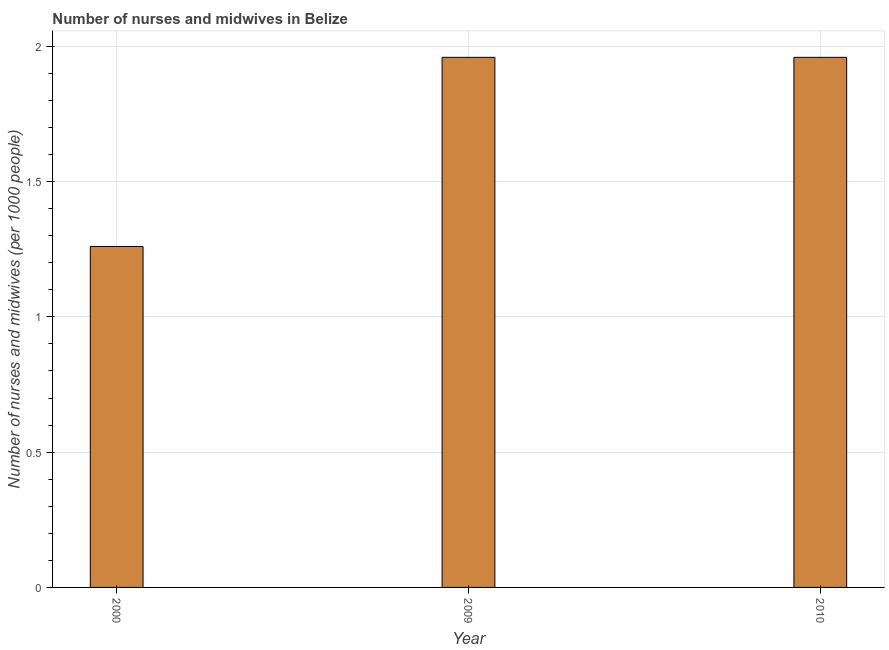Does the graph contain any zero values?
Provide a short and direct response. No. Does the graph contain grids?
Provide a succinct answer. Yes. What is the title of the graph?
Give a very brief answer. Number of nurses and midwives in Belize. What is the label or title of the Y-axis?
Your response must be concise. Number of nurses and midwives (per 1000 people). What is the number of nurses and midwives in 2010?
Your response must be concise. 1.96. Across all years, what is the maximum number of nurses and midwives?
Your answer should be compact. 1.96. Across all years, what is the minimum number of nurses and midwives?
Offer a very short reply. 1.26. In which year was the number of nurses and midwives minimum?
Keep it short and to the point. 2000. What is the sum of the number of nurses and midwives?
Provide a succinct answer. 5.18. What is the difference between the number of nurses and midwives in 2000 and 2009?
Your answer should be very brief. -0.7. What is the average number of nurses and midwives per year?
Provide a short and direct response. 1.73. What is the median number of nurses and midwives?
Make the answer very short. 1.96. What is the ratio of the number of nurses and midwives in 2000 to that in 2010?
Provide a succinct answer. 0.64. What is the difference between the highest and the second highest number of nurses and midwives?
Your answer should be compact. 0. Is the sum of the number of nurses and midwives in 2009 and 2010 greater than the maximum number of nurses and midwives across all years?
Your answer should be compact. Yes. What is the difference between the highest and the lowest number of nurses and midwives?
Provide a succinct answer. 0.7. In how many years, is the number of nurses and midwives greater than the average number of nurses and midwives taken over all years?
Offer a terse response. 2. How many bars are there?
Keep it short and to the point. 3. Are all the bars in the graph horizontal?
Give a very brief answer. No. How many years are there in the graph?
Your answer should be very brief. 3. Are the values on the major ticks of Y-axis written in scientific E-notation?
Ensure brevity in your answer.  No. What is the Number of nurses and midwives (per 1000 people) of 2000?
Give a very brief answer. 1.26. What is the Number of nurses and midwives (per 1000 people) in 2009?
Provide a succinct answer. 1.96. What is the Number of nurses and midwives (per 1000 people) in 2010?
Give a very brief answer. 1.96. What is the difference between the Number of nurses and midwives (per 1000 people) in 2000 and 2009?
Provide a succinct answer. -0.7. What is the difference between the Number of nurses and midwives (per 1000 people) in 2000 and 2010?
Provide a short and direct response. -0.7. What is the ratio of the Number of nurses and midwives (per 1000 people) in 2000 to that in 2009?
Keep it short and to the point. 0.64. What is the ratio of the Number of nurses and midwives (per 1000 people) in 2000 to that in 2010?
Your response must be concise. 0.64. 